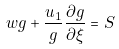Convert formula to latex. <formula><loc_0><loc_0><loc_500><loc_500>w g + \frac { u _ { 1 } } { g } \frac { \partial g } { \partial \xi } = S</formula> 